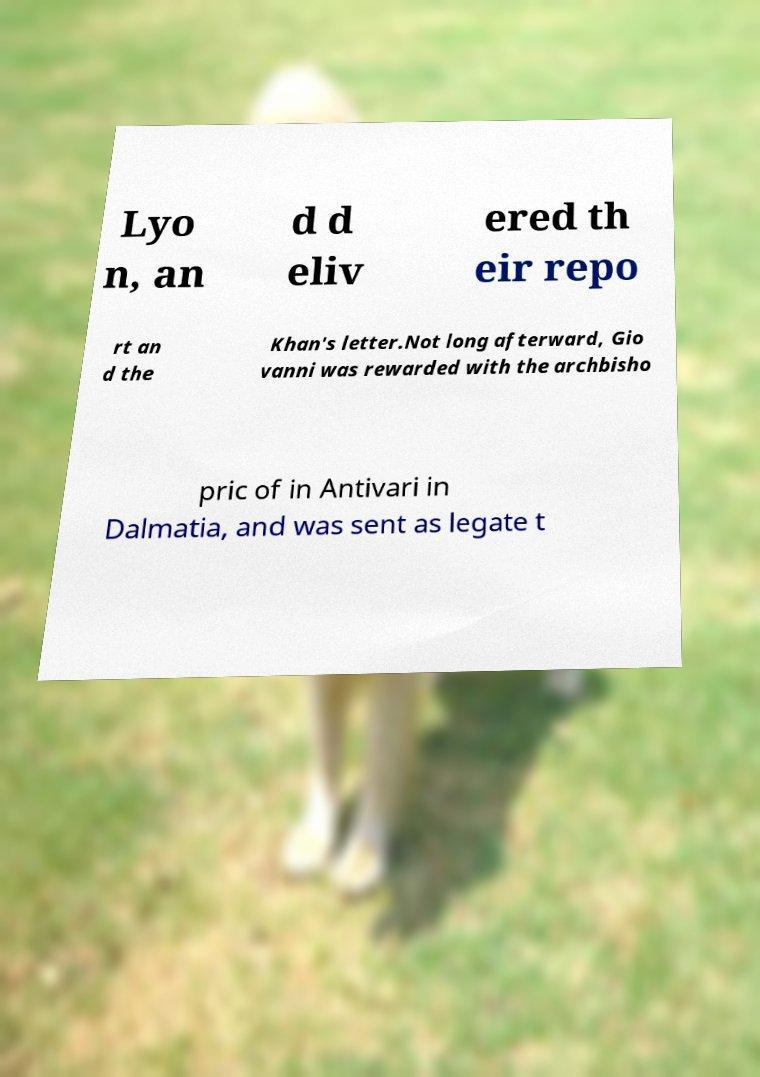Can you read and provide the text displayed in the image?This photo seems to have some interesting text. Can you extract and type it out for me? Lyo n, an d d eliv ered th eir repo rt an d the Khan's letter.Not long afterward, Gio vanni was rewarded with the archbisho pric of in Antivari in Dalmatia, and was sent as legate t 